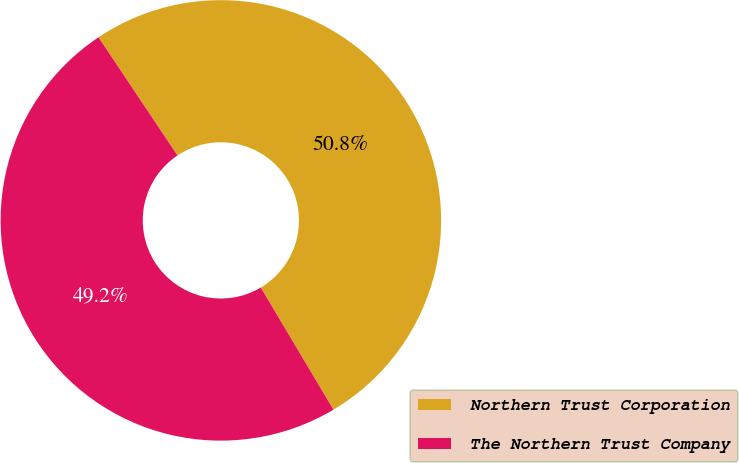Convert chart to OTSL. <chart><loc_0><loc_0><loc_500><loc_500><pie_chart><fcel>Northern Trust Corporation<fcel>The Northern Trust Company<nl><fcel>50.84%<fcel>49.16%<nl></chart> 